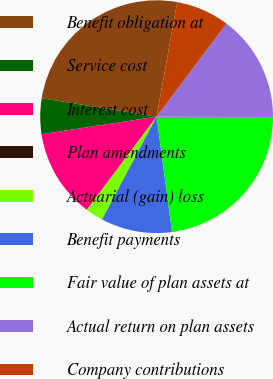<chart> <loc_0><loc_0><loc_500><loc_500><pie_chart><fcel>Benefit obligation at<fcel>Service cost<fcel>Interest cost<fcel>Plan amendments<fcel>Actuarial (gain) loss<fcel>Benefit payments<fcel>Fair value of plan assets at<fcel>Actual return on plan assets<fcel>Company contributions<nl><fcel>25.29%<fcel>4.94%<fcel>12.35%<fcel>0.0%<fcel>2.47%<fcel>9.88%<fcel>22.82%<fcel>14.82%<fcel>7.41%<nl></chart> 